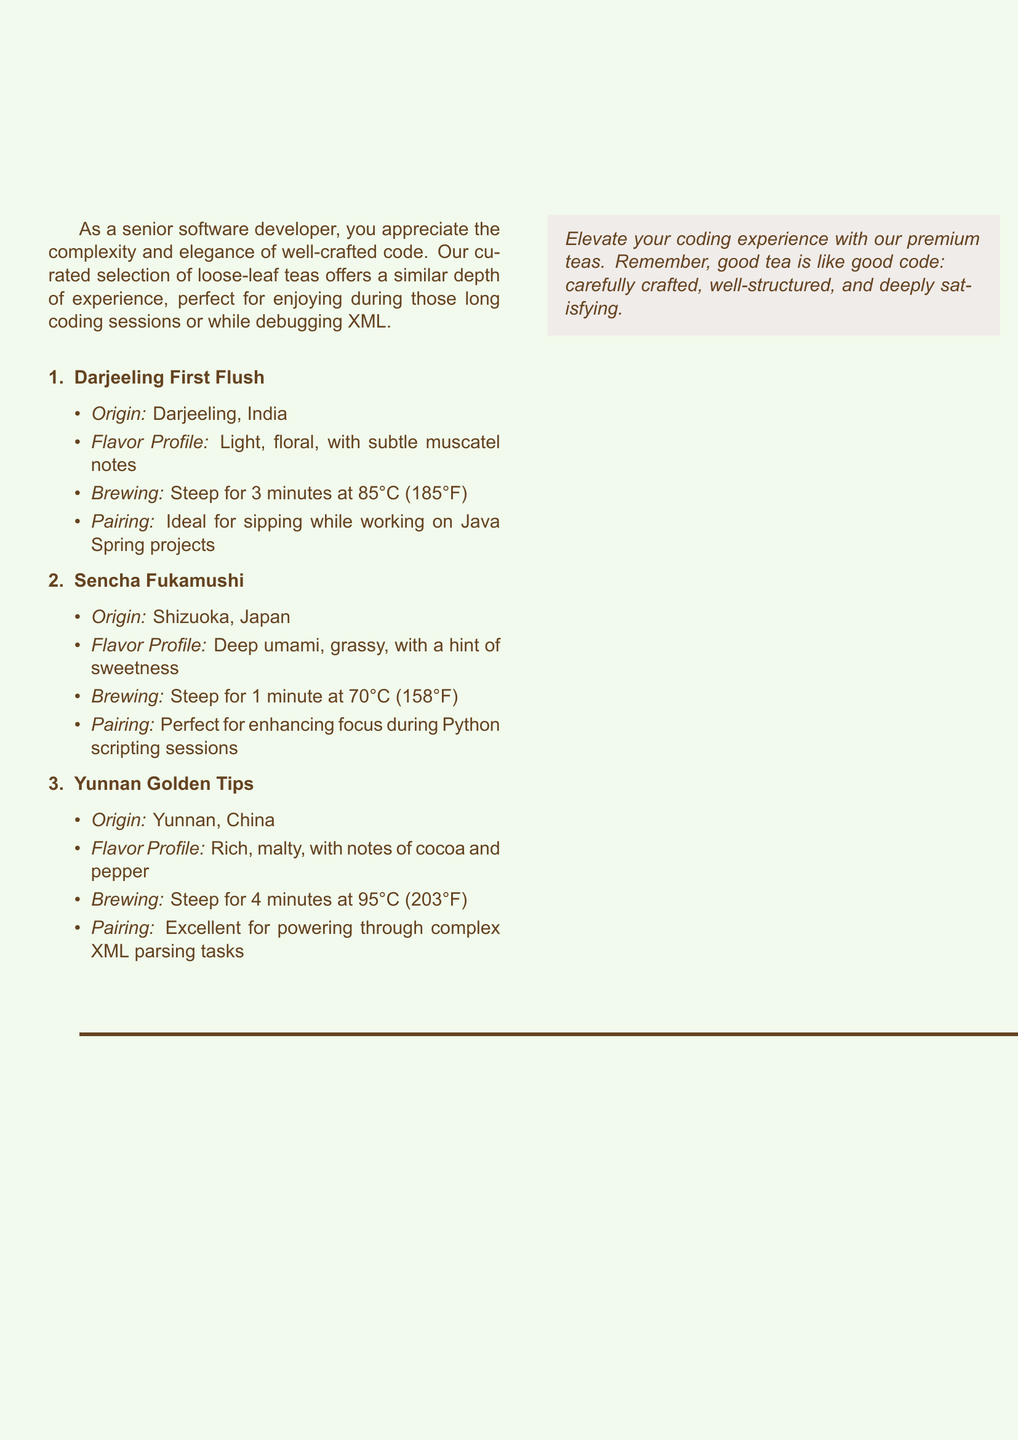What is the origin of Darjeeling First Flush? The origin of Darjeeling First Flush is stated as Darjeeling, India in the document.
Answer: Darjeeling, India What is the flavor profile of Sencha Fukamushi? The flavor profile of Sencha Fukamushi is described as deep umami, grassy, with a hint of sweetness.
Answer: Deep umami, grassy, with a hint of sweetness How long should Yunnan Golden Tips be steeped? The brewing instructions for Yunnan Golden Tips mention that it should be steeped for 4 minutes.
Answer: 4 minutes What tea is suggested for sipping while working on Java Spring projects? The document suggests Darjeeling First Flush for sipping while working on Java Spring projects.
Answer: Darjeeling First Flush What brewing temperature is recommended for Sencha Fukamushi? The document states that Sencha Fukamushi should be brewed at 70°C (158°F).
Answer: 70°C (158°F) Which tea is described as having notes of cocoa and pepper? Yunnan Golden Tips is described as having notes of cocoa and pepper in the document.
Answer: Yunnan Golden Tips What is the suggested pairing for enhancing focus during Python scripting sessions? The document suggests Sencha Fukamushi as the pairing for enhancing focus during Python scripting sessions.
Answer: Sencha Fukamushi What thematic element is emphasized in the document about tea and coding? The document emphasizes that both good tea and good code are carefully crafted, well-structured, and deeply satisfying.
Answer: Carefully crafted, well-structured, and deeply satisfying 